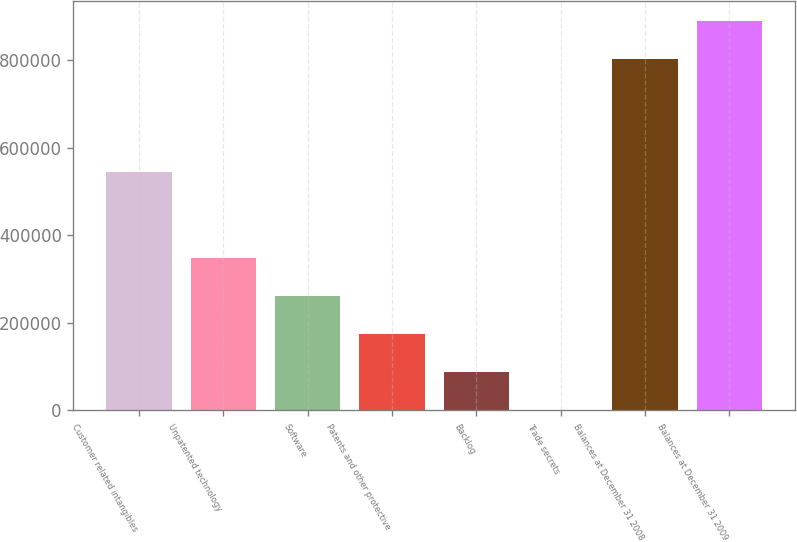<chart> <loc_0><loc_0><loc_500><loc_500><bar_chart><fcel>Customer related intangibles<fcel>Unpatented technology<fcel>Software<fcel>Patents and other protective<fcel>Backlog<fcel>Trade secrets<fcel>Balances at December 31 2008<fcel>Balances at December 31 2009<nl><fcel>545336<fcel>348296<fcel>261528<fcel>174761<fcel>87993.4<fcel>1226<fcel>804020<fcel>890787<nl></chart> 